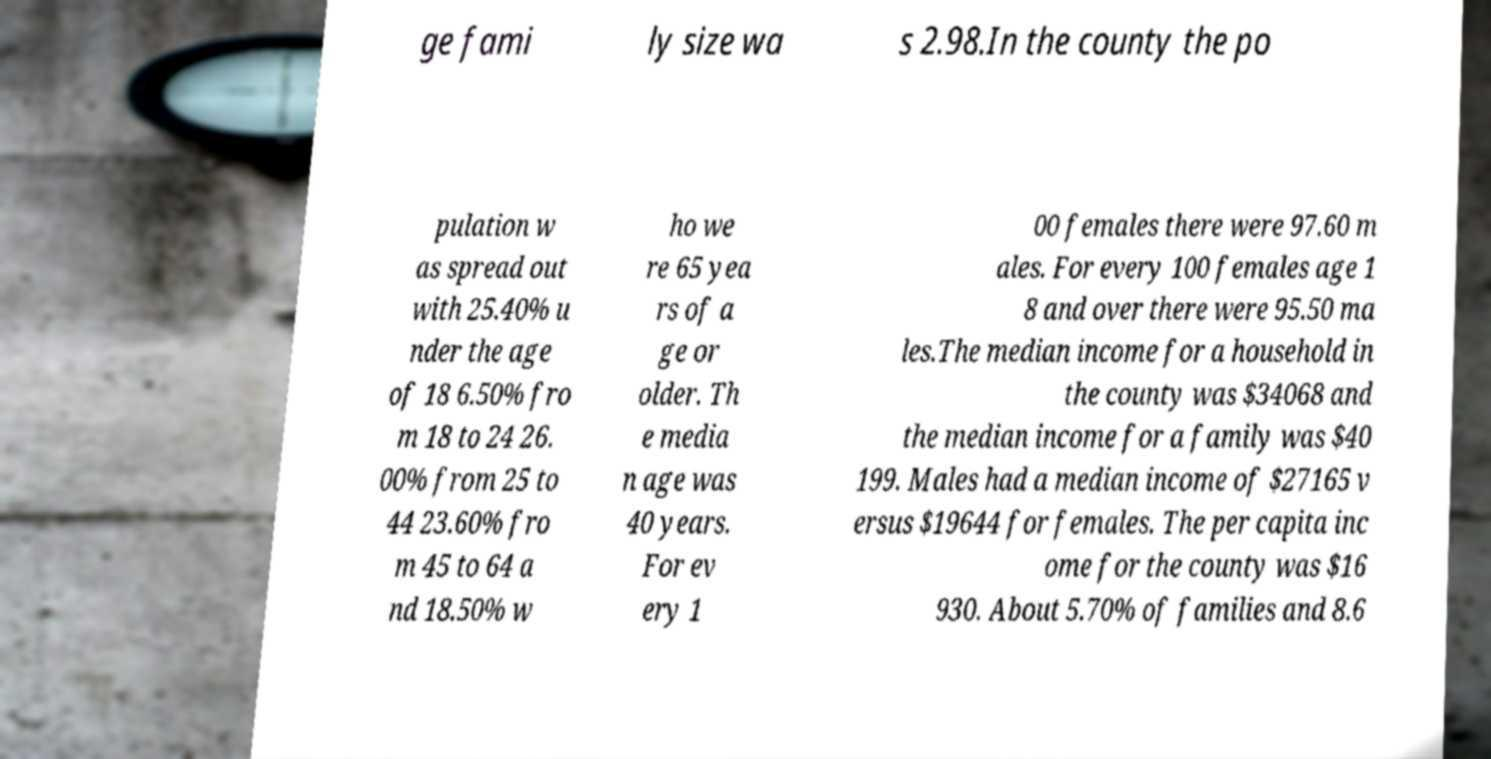What messages or text are displayed in this image? I need them in a readable, typed format. ge fami ly size wa s 2.98.In the county the po pulation w as spread out with 25.40% u nder the age of 18 6.50% fro m 18 to 24 26. 00% from 25 to 44 23.60% fro m 45 to 64 a nd 18.50% w ho we re 65 yea rs of a ge or older. Th e media n age was 40 years. For ev ery 1 00 females there were 97.60 m ales. For every 100 females age 1 8 and over there were 95.50 ma les.The median income for a household in the county was $34068 and the median income for a family was $40 199. Males had a median income of $27165 v ersus $19644 for females. The per capita inc ome for the county was $16 930. About 5.70% of families and 8.6 